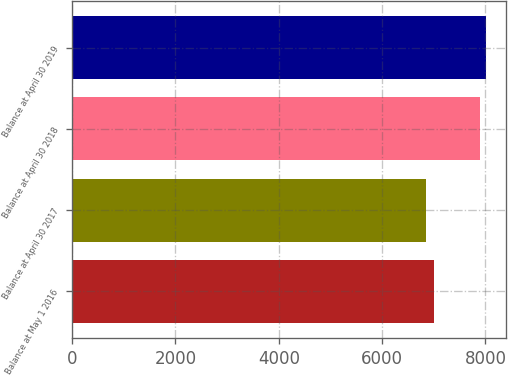<chart> <loc_0><loc_0><loc_500><loc_500><bar_chart><fcel>Balance at May 1 2016<fcel>Balance at April 30 2017<fcel>Balance at April 30 2018<fcel>Balance at April 30 2019<nl><fcel>7008.5<fcel>6850.2<fcel>7891.1<fcel>8003.13<nl></chart> 